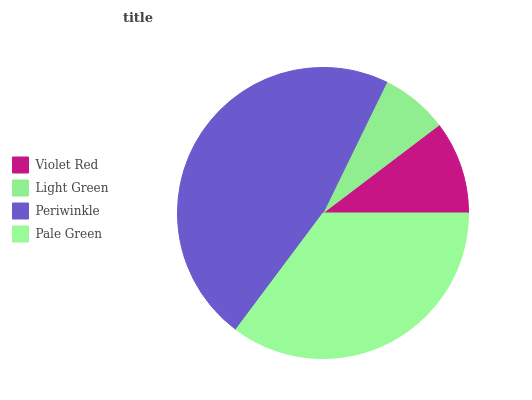Is Light Green the minimum?
Answer yes or no. Yes. Is Periwinkle the maximum?
Answer yes or no. Yes. Is Periwinkle the minimum?
Answer yes or no. No. Is Light Green the maximum?
Answer yes or no. No. Is Periwinkle greater than Light Green?
Answer yes or no. Yes. Is Light Green less than Periwinkle?
Answer yes or no. Yes. Is Light Green greater than Periwinkle?
Answer yes or no. No. Is Periwinkle less than Light Green?
Answer yes or no. No. Is Pale Green the high median?
Answer yes or no. Yes. Is Violet Red the low median?
Answer yes or no. Yes. Is Violet Red the high median?
Answer yes or no. No. Is Pale Green the low median?
Answer yes or no. No. 